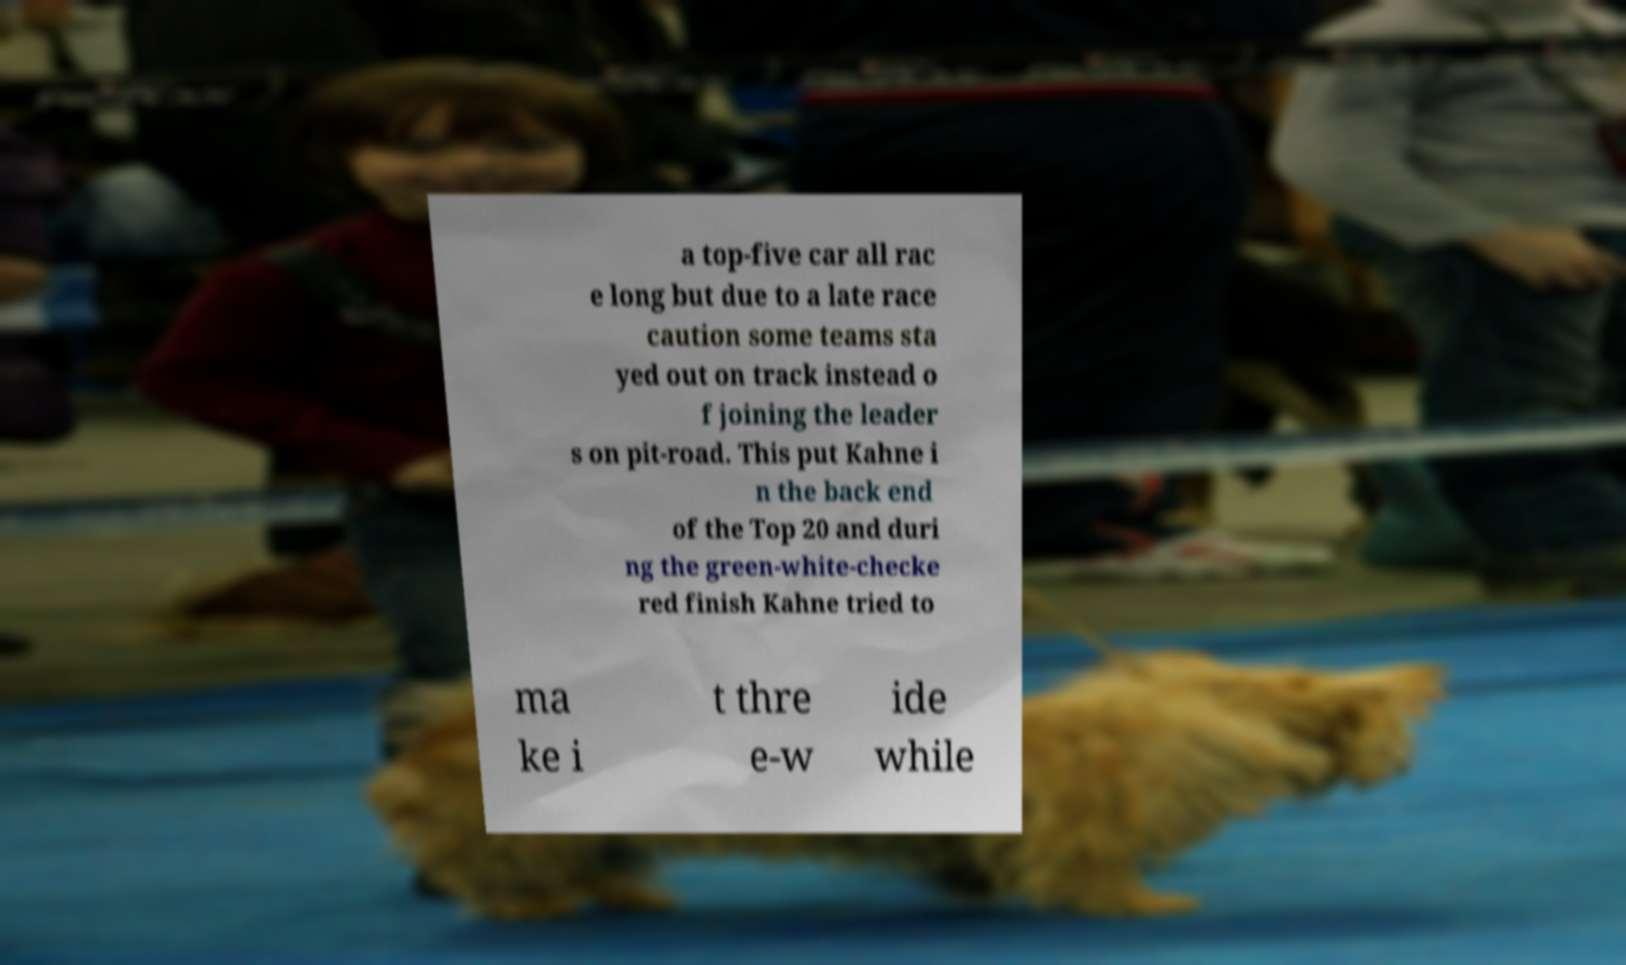Could you extract and type out the text from this image? a top-five car all rac e long but due to a late race caution some teams sta yed out on track instead o f joining the leader s on pit-road. This put Kahne i n the back end of the Top 20 and duri ng the green-white-checke red finish Kahne tried to ma ke i t thre e-w ide while 